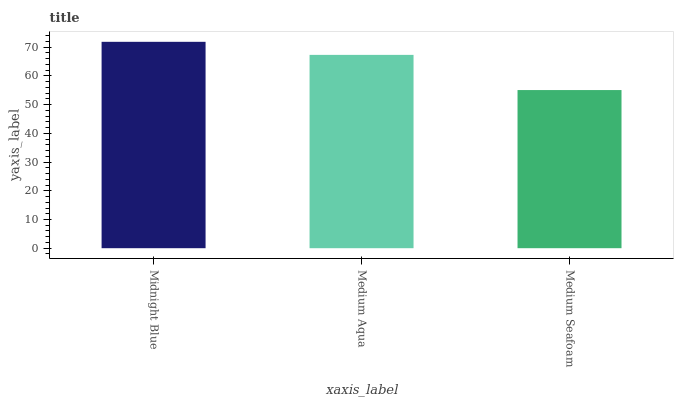Is Medium Seafoam the minimum?
Answer yes or no. Yes. Is Midnight Blue the maximum?
Answer yes or no. Yes. Is Medium Aqua the minimum?
Answer yes or no. No. Is Medium Aqua the maximum?
Answer yes or no. No. Is Midnight Blue greater than Medium Aqua?
Answer yes or no. Yes. Is Medium Aqua less than Midnight Blue?
Answer yes or no. Yes. Is Medium Aqua greater than Midnight Blue?
Answer yes or no. No. Is Midnight Blue less than Medium Aqua?
Answer yes or no. No. Is Medium Aqua the high median?
Answer yes or no. Yes. Is Medium Aqua the low median?
Answer yes or no. Yes. Is Medium Seafoam the high median?
Answer yes or no. No. Is Midnight Blue the low median?
Answer yes or no. No. 